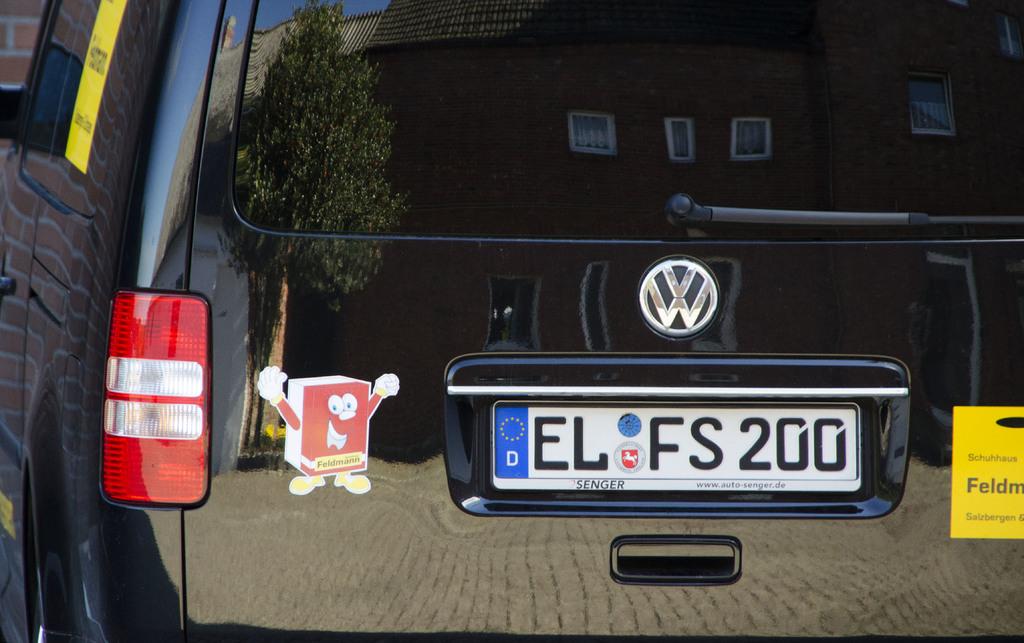What car company makes this car?
Offer a very short reply. Vw. What is the tag of the car?
Make the answer very short. El fs 200. 